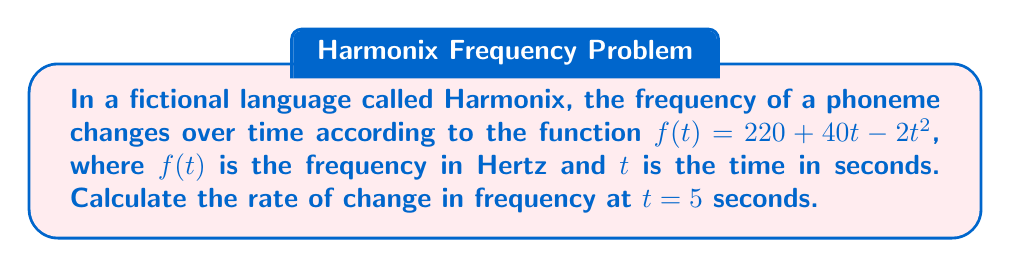Solve this math problem. To find the rate of change in frequency at a specific time, we need to calculate the derivative of the given function and evaluate it at the desired time point.

Step 1: Identify the function
$f(t) = 220 + 40t - 2t^2$

Step 2: Calculate the derivative
The derivative of a constant is 0, so:
$\frac{d}{dt}(220) = 0$
The derivative of $40t$ is 40, as the coefficient remains and the exponent becomes 0:
$\frac{d}{dt}(40t) = 40$
The derivative of $-2t^2$ follows the power rule, where we multiply by the exponent and reduce the exponent by 1:
$\frac{d}{dt}(-2t^2) = -2 \cdot 2t^1 = -4t$

Combining these results, we get:
$f'(t) = 0 + 40 + (-4t) = 40 - 4t$

Step 3: Evaluate the derivative at $t = 5$
$f'(5) = 40 - 4(5) = 40 - 20 = 20$

Therefore, the rate of change in frequency at $t = 5$ seconds is 20 Hz/s.
Answer: 20 Hz/s 